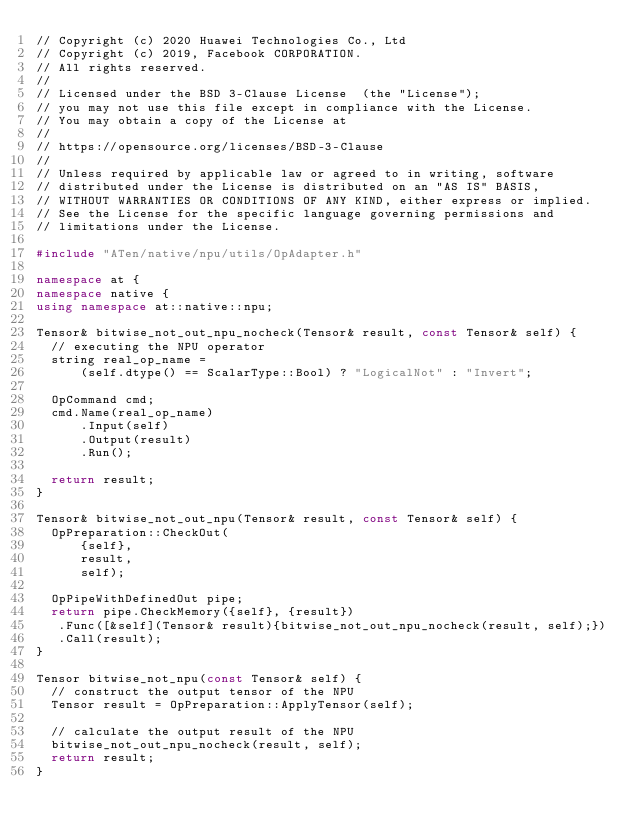Convert code to text. <code><loc_0><loc_0><loc_500><loc_500><_C++_>// Copyright (c) 2020 Huawei Technologies Co., Ltd
// Copyright (c) 2019, Facebook CORPORATION.
// All rights reserved.
//
// Licensed under the BSD 3-Clause License  (the "License");
// you may not use this file except in compliance with the License.
// You may obtain a copy of the License at
//
// https://opensource.org/licenses/BSD-3-Clause
//
// Unless required by applicable law or agreed to in writing, software
// distributed under the License is distributed on an "AS IS" BASIS,
// WITHOUT WARRANTIES OR CONDITIONS OF ANY KIND, either express or implied.
// See the License for the specific language governing permissions and
// limitations under the License.

#include "ATen/native/npu/utils/OpAdapter.h"

namespace at {
namespace native {
using namespace at::native::npu;

Tensor& bitwise_not_out_npu_nocheck(Tensor& result, const Tensor& self) {
  // executing the NPU operator
  string real_op_name =
      (self.dtype() == ScalarType::Bool) ? "LogicalNot" : "Invert";

  OpCommand cmd;
  cmd.Name(real_op_name)
      .Input(self)
      .Output(result)
      .Run();

  return result;
}

Tensor& bitwise_not_out_npu(Tensor& result, const Tensor& self) {
  OpPreparation::CheckOut(
      {self},
      result,
      self);

  OpPipeWithDefinedOut pipe;
  return pipe.CheckMemory({self}, {result})
   .Func([&self](Tensor& result){bitwise_not_out_npu_nocheck(result, self);})
   .Call(result);
}

Tensor bitwise_not_npu(const Tensor& self) {
  // construct the output tensor of the NPU
  Tensor result = OpPreparation::ApplyTensor(self);

  // calculate the output result of the NPU
  bitwise_not_out_npu_nocheck(result, self);
  return result;
}
</code> 